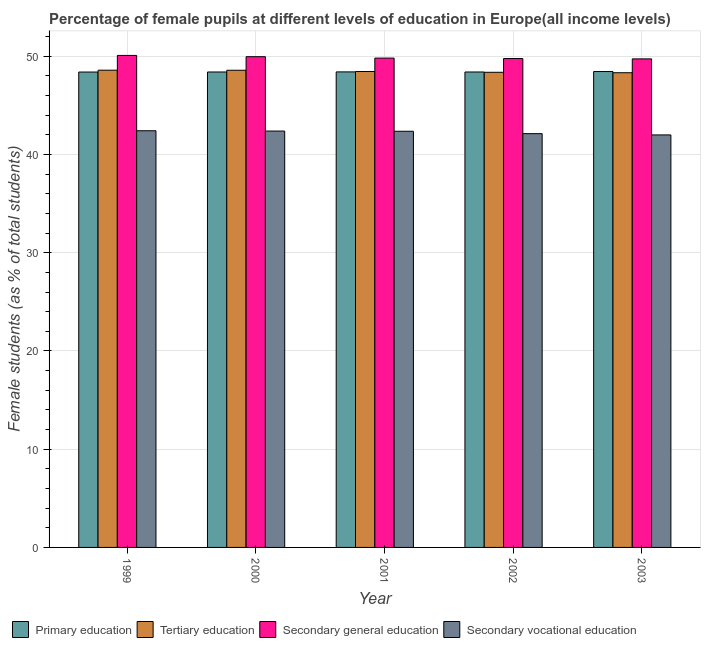How many different coloured bars are there?
Ensure brevity in your answer.  4. How many groups of bars are there?
Your answer should be very brief. 5. Are the number of bars per tick equal to the number of legend labels?
Provide a short and direct response. Yes. Are the number of bars on each tick of the X-axis equal?
Provide a short and direct response. Yes. How many bars are there on the 4th tick from the right?
Your answer should be very brief. 4. What is the label of the 2nd group of bars from the left?
Keep it short and to the point. 2000. In how many cases, is the number of bars for a given year not equal to the number of legend labels?
Make the answer very short. 0. What is the percentage of female students in secondary vocational education in 2000?
Offer a very short reply. 42.39. Across all years, what is the maximum percentage of female students in secondary education?
Your answer should be very brief. 50.09. Across all years, what is the minimum percentage of female students in primary education?
Your response must be concise. 48.4. In which year was the percentage of female students in secondary vocational education maximum?
Provide a short and direct response. 1999. In which year was the percentage of female students in tertiary education minimum?
Ensure brevity in your answer.  2003. What is the total percentage of female students in secondary vocational education in the graph?
Keep it short and to the point. 211.3. What is the difference between the percentage of female students in secondary vocational education in 2000 and that in 2001?
Make the answer very short. 0.02. What is the difference between the percentage of female students in secondary education in 2001 and the percentage of female students in tertiary education in 1999?
Your answer should be very brief. -0.27. What is the average percentage of female students in secondary vocational education per year?
Provide a short and direct response. 42.26. In the year 1999, what is the difference between the percentage of female students in tertiary education and percentage of female students in primary education?
Provide a short and direct response. 0. In how many years, is the percentage of female students in secondary education greater than 22 %?
Your answer should be compact. 5. What is the ratio of the percentage of female students in primary education in 1999 to that in 2002?
Your answer should be compact. 1. Is the difference between the percentage of female students in secondary education in 1999 and 2003 greater than the difference between the percentage of female students in secondary vocational education in 1999 and 2003?
Provide a short and direct response. No. What is the difference between the highest and the second highest percentage of female students in primary education?
Provide a succinct answer. 0.04. What is the difference between the highest and the lowest percentage of female students in tertiary education?
Give a very brief answer. 0.26. Is the sum of the percentage of female students in secondary vocational education in 1999 and 2001 greater than the maximum percentage of female students in primary education across all years?
Provide a succinct answer. Yes. Is it the case that in every year, the sum of the percentage of female students in tertiary education and percentage of female students in primary education is greater than the sum of percentage of female students in secondary education and percentage of female students in secondary vocational education?
Offer a very short reply. No. What does the 3rd bar from the left in 2001 represents?
Keep it short and to the point. Secondary general education. What does the 1st bar from the right in 2000 represents?
Offer a terse response. Secondary vocational education. Is it the case that in every year, the sum of the percentage of female students in primary education and percentage of female students in tertiary education is greater than the percentage of female students in secondary education?
Your response must be concise. Yes. How many bars are there?
Make the answer very short. 20. Are all the bars in the graph horizontal?
Offer a very short reply. No. Does the graph contain grids?
Make the answer very short. Yes. Where does the legend appear in the graph?
Provide a succinct answer. Bottom left. What is the title of the graph?
Offer a terse response. Percentage of female pupils at different levels of education in Europe(all income levels). What is the label or title of the X-axis?
Your response must be concise. Year. What is the label or title of the Y-axis?
Make the answer very short. Female students (as % of total students). What is the Female students (as % of total students) in Primary education in 1999?
Provide a short and direct response. 48.4. What is the Female students (as % of total students) of Tertiary education in 1999?
Provide a succinct answer. 48.59. What is the Female students (as % of total students) of Secondary general education in 1999?
Your answer should be very brief. 50.09. What is the Female students (as % of total students) in Secondary vocational education in 1999?
Give a very brief answer. 42.42. What is the Female students (as % of total students) of Primary education in 2000?
Your response must be concise. 48.4. What is the Female students (as % of total students) in Tertiary education in 2000?
Your answer should be very brief. 48.58. What is the Female students (as % of total students) of Secondary general education in 2000?
Provide a succinct answer. 49.96. What is the Female students (as % of total students) in Secondary vocational education in 2000?
Provide a succinct answer. 42.39. What is the Female students (as % of total students) in Primary education in 2001?
Make the answer very short. 48.41. What is the Female students (as % of total students) of Tertiary education in 2001?
Keep it short and to the point. 48.45. What is the Female students (as % of total students) of Secondary general education in 2001?
Offer a terse response. 49.82. What is the Female students (as % of total students) in Secondary vocational education in 2001?
Ensure brevity in your answer.  42.37. What is the Female students (as % of total students) of Primary education in 2002?
Keep it short and to the point. 48.4. What is the Female students (as % of total students) of Tertiary education in 2002?
Your answer should be very brief. 48.37. What is the Female students (as % of total students) of Secondary general education in 2002?
Your answer should be very brief. 49.77. What is the Female students (as % of total students) in Secondary vocational education in 2002?
Offer a terse response. 42.12. What is the Female students (as % of total students) in Primary education in 2003?
Offer a very short reply. 48.45. What is the Female students (as % of total students) in Tertiary education in 2003?
Make the answer very short. 48.33. What is the Female students (as % of total students) in Secondary general education in 2003?
Your answer should be very brief. 49.74. What is the Female students (as % of total students) of Secondary vocational education in 2003?
Your answer should be compact. 42. Across all years, what is the maximum Female students (as % of total students) in Primary education?
Make the answer very short. 48.45. Across all years, what is the maximum Female students (as % of total students) of Tertiary education?
Keep it short and to the point. 48.59. Across all years, what is the maximum Female students (as % of total students) in Secondary general education?
Ensure brevity in your answer.  50.09. Across all years, what is the maximum Female students (as % of total students) in Secondary vocational education?
Your response must be concise. 42.42. Across all years, what is the minimum Female students (as % of total students) in Primary education?
Keep it short and to the point. 48.4. Across all years, what is the minimum Female students (as % of total students) of Tertiary education?
Ensure brevity in your answer.  48.33. Across all years, what is the minimum Female students (as % of total students) in Secondary general education?
Ensure brevity in your answer.  49.74. Across all years, what is the minimum Female students (as % of total students) of Secondary vocational education?
Provide a succinct answer. 42. What is the total Female students (as % of total students) in Primary education in the graph?
Your answer should be very brief. 242.06. What is the total Female students (as % of total students) in Tertiary education in the graph?
Provide a succinct answer. 242.32. What is the total Female students (as % of total students) of Secondary general education in the graph?
Your response must be concise. 249.37. What is the total Female students (as % of total students) in Secondary vocational education in the graph?
Keep it short and to the point. 211.3. What is the difference between the Female students (as % of total students) in Primary education in 1999 and that in 2000?
Provide a short and direct response. -0.01. What is the difference between the Female students (as % of total students) of Tertiary education in 1999 and that in 2000?
Keep it short and to the point. 0.01. What is the difference between the Female students (as % of total students) of Secondary general education in 1999 and that in 2000?
Make the answer very short. 0.13. What is the difference between the Female students (as % of total students) in Secondary vocational education in 1999 and that in 2000?
Offer a terse response. 0.03. What is the difference between the Female students (as % of total students) of Primary education in 1999 and that in 2001?
Make the answer very short. -0.01. What is the difference between the Female students (as % of total students) in Tertiary education in 1999 and that in 2001?
Your answer should be compact. 0.13. What is the difference between the Female students (as % of total students) in Secondary general education in 1999 and that in 2001?
Offer a terse response. 0.27. What is the difference between the Female students (as % of total students) of Secondary vocational education in 1999 and that in 2001?
Make the answer very short. 0.05. What is the difference between the Female students (as % of total students) of Primary education in 1999 and that in 2002?
Make the answer very short. -0.01. What is the difference between the Female students (as % of total students) in Tertiary education in 1999 and that in 2002?
Provide a succinct answer. 0.21. What is the difference between the Female students (as % of total students) of Secondary general education in 1999 and that in 2002?
Give a very brief answer. 0.32. What is the difference between the Female students (as % of total students) in Secondary vocational education in 1999 and that in 2002?
Make the answer very short. 0.29. What is the difference between the Female students (as % of total students) of Primary education in 1999 and that in 2003?
Your response must be concise. -0.05. What is the difference between the Female students (as % of total students) of Tertiary education in 1999 and that in 2003?
Make the answer very short. 0.26. What is the difference between the Female students (as % of total students) in Secondary general education in 1999 and that in 2003?
Your response must be concise. 0.35. What is the difference between the Female students (as % of total students) in Secondary vocational education in 1999 and that in 2003?
Your response must be concise. 0.42. What is the difference between the Female students (as % of total students) of Primary education in 2000 and that in 2001?
Provide a short and direct response. -0.01. What is the difference between the Female students (as % of total students) in Tertiary education in 2000 and that in 2001?
Your response must be concise. 0.13. What is the difference between the Female students (as % of total students) of Secondary general education in 2000 and that in 2001?
Offer a very short reply. 0.14. What is the difference between the Female students (as % of total students) in Secondary vocational education in 2000 and that in 2001?
Provide a succinct answer. 0.02. What is the difference between the Female students (as % of total students) of Primary education in 2000 and that in 2002?
Keep it short and to the point. -0. What is the difference between the Female students (as % of total students) in Tertiary education in 2000 and that in 2002?
Make the answer very short. 0.21. What is the difference between the Female students (as % of total students) in Secondary general education in 2000 and that in 2002?
Keep it short and to the point. 0.19. What is the difference between the Female students (as % of total students) in Secondary vocational education in 2000 and that in 2002?
Keep it short and to the point. 0.26. What is the difference between the Female students (as % of total students) of Primary education in 2000 and that in 2003?
Your answer should be very brief. -0.05. What is the difference between the Female students (as % of total students) in Tertiary education in 2000 and that in 2003?
Your response must be concise. 0.25. What is the difference between the Female students (as % of total students) in Secondary general education in 2000 and that in 2003?
Provide a succinct answer. 0.22. What is the difference between the Female students (as % of total students) of Secondary vocational education in 2000 and that in 2003?
Offer a very short reply. 0.39. What is the difference between the Female students (as % of total students) of Primary education in 2001 and that in 2002?
Offer a terse response. 0.01. What is the difference between the Female students (as % of total students) of Tertiary education in 2001 and that in 2002?
Make the answer very short. 0.08. What is the difference between the Female students (as % of total students) in Secondary general education in 2001 and that in 2002?
Make the answer very short. 0.05. What is the difference between the Female students (as % of total students) in Secondary vocational education in 2001 and that in 2002?
Give a very brief answer. 0.24. What is the difference between the Female students (as % of total students) in Primary education in 2001 and that in 2003?
Keep it short and to the point. -0.04. What is the difference between the Female students (as % of total students) in Tertiary education in 2001 and that in 2003?
Offer a very short reply. 0.12. What is the difference between the Female students (as % of total students) in Secondary general education in 2001 and that in 2003?
Your answer should be compact. 0.08. What is the difference between the Female students (as % of total students) of Secondary vocational education in 2001 and that in 2003?
Make the answer very short. 0.37. What is the difference between the Female students (as % of total students) of Primary education in 2002 and that in 2003?
Your answer should be very brief. -0.05. What is the difference between the Female students (as % of total students) in Tertiary education in 2002 and that in 2003?
Ensure brevity in your answer.  0.05. What is the difference between the Female students (as % of total students) of Secondary general education in 2002 and that in 2003?
Ensure brevity in your answer.  0.03. What is the difference between the Female students (as % of total students) in Secondary vocational education in 2002 and that in 2003?
Provide a short and direct response. 0.13. What is the difference between the Female students (as % of total students) of Primary education in 1999 and the Female students (as % of total students) of Tertiary education in 2000?
Your response must be concise. -0.18. What is the difference between the Female students (as % of total students) in Primary education in 1999 and the Female students (as % of total students) in Secondary general education in 2000?
Give a very brief answer. -1.56. What is the difference between the Female students (as % of total students) in Primary education in 1999 and the Female students (as % of total students) in Secondary vocational education in 2000?
Offer a terse response. 6.01. What is the difference between the Female students (as % of total students) of Tertiary education in 1999 and the Female students (as % of total students) of Secondary general education in 2000?
Your response must be concise. -1.37. What is the difference between the Female students (as % of total students) of Tertiary education in 1999 and the Female students (as % of total students) of Secondary vocational education in 2000?
Provide a short and direct response. 6.2. What is the difference between the Female students (as % of total students) of Secondary general education in 1999 and the Female students (as % of total students) of Secondary vocational education in 2000?
Your response must be concise. 7.7. What is the difference between the Female students (as % of total students) of Primary education in 1999 and the Female students (as % of total students) of Tertiary education in 2001?
Keep it short and to the point. -0.06. What is the difference between the Female students (as % of total students) in Primary education in 1999 and the Female students (as % of total students) in Secondary general education in 2001?
Your answer should be very brief. -1.42. What is the difference between the Female students (as % of total students) in Primary education in 1999 and the Female students (as % of total students) in Secondary vocational education in 2001?
Make the answer very short. 6.03. What is the difference between the Female students (as % of total students) of Tertiary education in 1999 and the Female students (as % of total students) of Secondary general education in 2001?
Your answer should be compact. -1.23. What is the difference between the Female students (as % of total students) of Tertiary education in 1999 and the Female students (as % of total students) of Secondary vocational education in 2001?
Your answer should be compact. 6.22. What is the difference between the Female students (as % of total students) in Secondary general education in 1999 and the Female students (as % of total students) in Secondary vocational education in 2001?
Ensure brevity in your answer.  7.72. What is the difference between the Female students (as % of total students) in Primary education in 1999 and the Female students (as % of total students) in Tertiary education in 2002?
Provide a short and direct response. 0.02. What is the difference between the Female students (as % of total students) of Primary education in 1999 and the Female students (as % of total students) of Secondary general education in 2002?
Provide a short and direct response. -1.37. What is the difference between the Female students (as % of total students) in Primary education in 1999 and the Female students (as % of total students) in Secondary vocational education in 2002?
Keep it short and to the point. 6.27. What is the difference between the Female students (as % of total students) of Tertiary education in 1999 and the Female students (as % of total students) of Secondary general education in 2002?
Your answer should be very brief. -1.18. What is the difference between the Female students (as % of total students) in Tertiary education in 1999 and the Female students (as % of total students) in Secondary vocational education in 2002?
Offer a very short reply. 6.46. What is the difference between the Female students (as % of total students) in Secondary general education in 1999 and the Female students (as % of total students) in Secondary vocational education in 2002?
Offer a terse response. 7.96. What is the difference between the Female students (as % of total students) of Primary education in 1999 and the Female students (as % of total students) of Tertiary education in 2003?
Offer a terse response. 0.07. What is the difference between the Female students (as % of total students) in Primary education in 1999 and the Female students (as % of total students) in Secondary general education in 2003?
Your answer should be compact. -1.34. What is the difference between the Female students (as % of total students) in Primary education in 1999 and the Female students (as % of total students) in Secondary vocational education in 2003?
Offer a terse response. 6.4. What is the difference between the Female students (as % of total students) of Tertiary education in 1999 and the Female students (as % of total students) of Secondary general education in 2003?
Offer a terse response. -1.15. What is the difference between the Female students (as % of total students) in Tertiary education in 1999 and the Female students (as % of total students) in Secondary vocational education in 2003?
Provide a short and direct response. 6.59. What is the difference between the Female students (as % of total students) of Secondary general education in 1999 and the Female students (as % of total students) of Secondary vocational education in 2003?
Give a very brief answer. 8.09. What is the difference between the Female students (as % of total students) in Primary education in 2000 and the Female students (as % of total students) in Tertiary education in 2001?
Provide a short and direct response. -0.05. What is the difference between the Female students (as % of total students) of Primary education in 2000 and the Female students (as % of total students) of Secondary general education in 2001?
Keep it short and to the point. -1.41. What is the difference between the Female students (as % of total students) in Primary education in 2000 and the Female students (as % of total students) in Secondary vocational education in 2001?
Provide a short and direct response. 6.03. What is the difference between the Female students (as % of total students) of Tertiary education in 2000 and the Female students (as % of total students) of Secondary general education in 2001?
Give a very brief answer. -1.24. What is the difference between the Female students (as % of total students) of Tertiary education in 2000 and the Female students (as % of total students) of Secondary vocational education in 2001?
Your answer should be compact. 6.21. What is the difference between the Female students (as % of total students) in Secondary general education in 2000 and the Female students (as % of total students) in Secondary vocational education in 2001?
Offer a very short reply. 7.59. What is the difference between the Female students (as % of total students) of Primary education in 2000 and the Female students (as % of total students) of Tertiary education in 2002?
Offer a very short reply. 0.03. What is the difference between the Female students (as % of total students) of Primary education in 2000 and the Female students (as % of total students) of Secondary general education in 2002?
Your answer should be compact. -1.37. What is the difference between the Female students (as % of total students) of Primary education in 2000 and the Female students (as % of total students) of Secondary vocational education in 2002?
Make the answer very short. 6.28. What is the difference between the Female students (as % of total students) in Tertiary education in 2000 and the Female students (as % of total students) in Secondary general education in 2002?
Your answer should be very brief. -1.19. What is the difference between the Female students (as % of total students) in Tertiary education in 2000 and the Female students (as % of total students) in Secondary vocational education in 2002?
Keep it short and to the point. 6.45. What is the difference between the Female students (as % of total students) of Secondary general education in 2000 and the Female students (as % of total students) of Secondary vocational education in 2002?
Offer a terse response. 7.83. What is the difference between the Female students (as % of total students) in Primary education in 2000 and the Female students (as % of total students) in Tertiary education in 2003?
Make the answer very short. 0.07. What is the difference between the Female students (as % of total students) of Primary education in 2000 and the Female students (as % of total students) of Secondary general education in 2003?
Make the answer very short. -1.33. What is the difference between the Female students (as % of total students) in Primary education in 2000 and the Female students (as % of total students) in Secondary vocational education in 2003?
Offer a terse response. 6.41. What is the difference between the Female students (as % of total students) in Tertiary education in 2000 and the Female students (as % of total students) in Secondary general education in 2003?
Your response must be concise. -1.16. What is the difference between the Female students (as % of total students) in Tertiary education in 2000 and the Female students (as % of total students) in Secondary vocational education in 2003?
Give a very brief answer. 6.58. What is the difference between the Female students (as % of total students) of Secondary general education in 2000 and the Female students (as % of total students) of Secondary vocational education in 2003?
Make the answer very short. 7.96. What is the difference between the Female students (as % of total students) of Primary education in 2001 and the Female students (as % of total students) of Tertiary education in 2002?
Provide a short and direct response. 0.04. What is the difference between the Female students (as % of total students) of Primary education in 2001 and the Female students (as % of total students) of Secondary general education in 2002?
Give a very brief answer. -1.36. What is the difference between the Female students (as % of total students) in Primary education in 2001 and the Female students (as % of total students) in Secondary vocational education in 2002?
Your answer should be very brief. 6.29. What is the difference between the Female students (as % of total students) in Tertiary education in 2001 and the Female students (as % of total students) in Secondary general education in 2002?
Your response must be concise. -1.32. What is the difference between the Female students (as % of total students) of Tertiary education in 2001 and the Female students (as % of total students) of Secondary vocational education in 2002?
Keep it short and to the point. 6.33. What is the difference between the Female students (as % of total students) in Secondary general education in 2001 and the Female students (as % of total students) in Secondary vocational education in 2002?
Your response must be concise. 7.69. What is the difference between the Female students (as % of total students) of Primary education in 2001 and the Female students (as % of total students) of Tertiary education in 2003?
Offer a terse response. 0.08. What is the difference between the Female students (as % of total students) in Primary education in 2001 and the Female students (as % of total students) in Secondary general education in 2003?
Give a very brief answer. -1.32. What is the difference between the Female students (as % of total students) in Primary education in 2001 and the Female students (as % of total students) in Secondary vocational education in 2003?
Provide a succinct answer. 6.42. What is the difference between the Female students (as % of total students) in Tertiary education in 2001 and the Female students (as % of total students) in Secondary general education in 2003?
Provide a short and direct response. -1.28. What is the difference between the Female students (as % of total students) in Tertiary education in 2001 and the Female students (as % of total students) in Secondary vocational education in 2003?
Provide a short and direct response. 6.46. What is the difference between the Female students (as % of total students) in Secondary general education in 2001 and the Female students (as % of total students) in Secondary vocational education in 2003?
Keep it short and to the point. 7.82. What is the difference between the Female students (as % of total students) of Primary education in 2002 and the Female students (as % of total students) of Tertiary education in 2003?
Provide a succinct answer. 0.08. What is the difference between the Female students (as % of total students) in Primary education in 2002 and the Female students (as % of total students) in Secondary general education in 2003?
Your response must be concise. -1.33. What is the difference between the Female students (as % of total students) in Primary education in 2002 and the Female students (as % of total students) in Secondary vocational education in 2003?
Provide a succinct answer. 6.41. What is the difference between the Female students (as % of total students) in Tertiary education in 2002 and the Female students (as % of total students) in Secondary general education in 2003?
Provide a short and direct response. -1.36. What is the difference between the Female students (as % of total students) in Tertiary education in 2002 and the Female students (as % of total students) in Secondary vocational education in 2003?
Ensure brevity in your answer.  6.38. What is the difference between the Female students (as % of total students) of Secondary general education in 2002 and the Female students (as % of total students) of Secondary vocational education in 2003?
Keep it short and to the point. 7.77. What is the average Female students (as % of total students) in Primary education per year?
Your response must be concise. 48.41. What is the average Female students (as % of total students) of Tertiary education per year?
Give a very brief answer. 48.46. What is the average Female students (as % of total students) of Secondary general education per year?
Keep it short and to the point. 49.87. What is the average Female students (as % of total students) in Secondary vocational education per year?
Ensure brevity in your answer.  42.26. In the year 1999, what is the difference between the Female students (as % of total students) in Primary education and Female students (as % of total students) in Tertiary education?
Offer a terse response. -0.19. In the year 1999, what is the difference between the Female students (as % of total students) in Primary education and Female students (as % of total students) in Secondary general education?
Offer a very short reply. -1.69. In the year 1999, what is the difference between the Female students (as % of total students) in Primary education and Female students (as % of total students) in Secondary vocational education?
Make the answer very short. 5.98. In the year 1999, what is the difference between the Female students (as % of total students) of Tertiary education and Female students (as % of total students) of Secondary general education?
Offer a very short reply. -1.5. In the year 1999, what is the difference between the Female students (as % of total students) in Tertiary education and Female students (as % of total students) in Secondary vocational education?
Make the answer very short. 6.17. In the year 1999, what is the difference between the Female students (as % of total students) of Secondary general education and Female students (as % of total students) of Secondary vocational education?
Keep it short and to the point. 7.67. In the year 2000, what is the difference between the Female students (as % of total students) of Primary education and Female students (as % of total students) of Tertiary education?
Ensure brevity in your answer.  -0.18. In the year 2000, what is the difference between the Female students (as % of total students) of Primary education and Female students (as % of total students) of Secondary general education?
Keep it short and to the point. -1.56. In the year 2000, what is the difference between the Female students (as % of total students) of Primary education and Female students (as % of total students) of Secondary vocational education?
Give a very brief answer. 6.01. In the year 2000, what is the difference between the Female students (as % of total students) in Tertiary education and Female students (as % of total students) in Secondary general education?
Keep it short and to the point. -1.38. In the year 2000, what is the difference between the Female students (as % of total students) of Tertiary education and Female students (as % of total students) of Secondary vocational education?
Give a very brief answer. 6.19. In the year 2000, what is the difference between the Female students (as % of total students) in Secondary general education and Female students (as % of total students) in Secondary vocational education?
Provide a short and direct response. 7.57. In the year 2001, what is the difference between the Female students (as % of total students) in Primary education and Female students (as % of total students) in Tertiary education?
Give a very brief answer. -0.04. In the year 2001, what is the difference between the Female students (as % of total students) of Primary education and Female students (as % of total students) of Secondary general education?
Provide a short and direct response. -1.41. In the year 2001, what is the difference between the Female students (as % of total students) of Primary education and Female students (as % of total students) of Secondary vocational education?
Provide a short and direct response. 6.04. In the year 2001, what is the difference between the Female students (as % of total students) of Tertiary education and Female students (as % of total students) of Secondary general education?
Your response must be concise. -1.36. In the year 2001, what is the difference between the Female students (as % of total students) in Tertiary education and Female students (as % of total students) in Secondary vocational education?
Make the answer very short. 6.08. In the year 2001, what is the difference between the Female students (as % of total students) in Secondary general education and Female students (as % of total students) in Secondary vocational education?
Keep it short and to the point. 7.45. In the year 2002, what is the difference between the Female students (as % of total students) in Primary education and Female students (as % of total students) in Tertiary education?
Keep it short and to the point. 0.03. In the year 2002, what is the difference between the Female students (as % of total students) in Primary education and Female students (as % of total students) in Secondary general education?
Provide a succinct answer. -1.37. In the year 2002, what is the difference between the Female students (as % of total students) in Primary education and Female students (as % of total students) in Secondary vocational education?
Provide a succinct answer. 6.28. In the year 2002, what is the difference between the Female students (as % of total students) in Tertiary education and Female students (as % of total students) in Secondary general education?
Keep it short and to the point. -1.4. In the year 2002, what is the difference between the Female students (as % of total students) in Tertiary education and Female students (as % of total students) in Secondary vocational education?
Your answer should be compact. 6.25. In the year 2002, what is the difference between the Female students (as % of total students) of Secondary general education and Female students (as % of total students) of Secondary vocational education?
Your answer should be compact. 7.64. In the year 2003, what is the difference between the Female students (as % of total students) of Primary education and Female students (as % of total students) of Tertiary education?
Offer a very short reply. 0.12. In the year 2003, what is the difference between the Female students (as % of total students) of Primary education and Female students (as % of total students) of Secondary general education?
Provide a short and direct response. -1.29. In the year 2003, what is the difference between the Female students (as % of total students) in Primary education and Female students (as % of total students) in Secondary vocational education?
Provide a succinct answer. 6.45. In the year 2003, what is the difference between the Female students (as % of total students) of Tertiary education and Female students (as % of total students) of Secondary general education?
Offer a terse response. -1.41. In the year 2003, what is the difference between the Female students (as % of total students) in Tertiary education and Female students (as % of total students) in Secondary vocational education?
Give a very brief answer. 6.33. In the year 2003, what is the difference between the Female students (as % of total students) of Secondary general education and Female students (as % of total students) of Secondary vocational education?
Keep it short and to the point. 7.74. What is the ratio of the Female students (as % of total students) of Primary education in 1999 to that in 2001?
Provide a short and direct response. 1. What is the ratio of the Female students (as % of total students) of Tertiary education in 1999 to that in 2001?
Give a very brief answer. 1. What is the ratio of the Female students (as % of total students) of Secondary vocational education in 1999 to that in 2001?
Make the answer very short. 1. What is the ratio of the Female students (as % of total students) in Tertiary education in 1999 to that in 2002?
Offer a terse response. 1. What is the ratio of the Female students (as % of total students) in Secondary general education in 1999 to that in 2002?
Provide a succinct answer. 1.01. What is the ratio of the Female students (as % of total students) of Secondary vocational education in 1999 to that in 2002?
Make the answer very short. 1.01. What is the ratio of the Female students (as % of total students) of Primary education in 1999 to that in 2003?
Keep it short and to the point. 1. What is the ratio of the Female students (as % of total students) in Tertiary education in 1999 to that in 2003?
Keep it short and to the point. 1.01. What is the ratio of the Female students (as % of total students) in Secondary general education in 1999 to that in 2003?
Provide a short and direct response. 1.01. What is the ratio of the Female students (as % of total students) in Primary education in 2000 to that in 2001?
Keep it short and to the point. 1. What is the ratio of the Female students (as % of total students) in Tertiary education in 2000 to that in 2001?
Provide a succinct answer. 1. What is the ratio of the Female students (as % of total students) in Secondary general education in 2000 to that in 2001?
Make the answer very short. 1. What is the ratio of the Female students (as % of total students) in Secondary vocational education in 2000 to that in 2001?
Your response must be concise. 1. What is the ratio of the Female students (as % of total students) of Tertiary education in 2000 to that in 2002?
Keep it short and to the point. 1. What is the ratio of the Female students (as % of total students) in Secondary general education in 2000 to that in 2002?
Your answer should be very brief. 1. What is the ratio of the Female students (as % of total students) in Primary education in 2000 to that in 2003?
Provide a short and direct response. 1. What is the ratio of the Female students (as % of total students) in Tertiary education in 2000 to that in 2003?
Give a very brief answer. 1.01. What is the ratio of the Female students (as % of total students) in Secondary vocational education in 2000 to that in 2003?
Provide a succinct answer. 1.01. What is the ratio of the Female students (as % of total students) of Tertiary education in 2001 to that in 2002?
Offer a terse response. 1. What is the ratio of the Female students (as % of total students) of Secondary general education in 2001 to that in 2002?
Provide a succinct answer. 1. What is the ratio of the Female students (as % of total students) in Secondary vocational education in 2001 to that in 2002?
Offer a very short reply. 1.01. What is the ratio of the Female students (as % of total students) of Primary education in 2001 to that in 2003?
Give a very brief answer. 1. What is the ratio of the Female students (as % of total students) in Tertiary education in 2001 to that in 2003?
Your response must be concise. 1. What is the ratio of the Female students (as % of total students) in Secondary vocational education in 2001 to that in 2003?
Provide a succinct answer. 1.01. What is the ratio of the Female students (as % of total students) in Secondary general education in 2002 to that in 2003?
Provide a short and direct response. 1. What is the difference between the highest and the second highest Female students (as % of total students) in Primary education?
Provide a short and direct response. 0.04. What is the difference between the highest and the second highest Female students (as % of total students) in Tertiary education?
Your answer should be compact. 0.01. What is the difference between the highest and the second highest Female students (as % of total students) of Secondary general education?
Offer a very short reply. 0.13. What is the difference between the highest and the second highest Female students (as % of total students) in Secondary vocational education?
Offer a very short reply. 0.03. What is the difference between the highest and the lowest Female students (as % of total students) of Primary education?
Keep it short and to the point. 0.05. What is the difference between the highest and the lowest Female students (as % of total students) of Tertiary education?
Give a very brief answer. 0.26. What is the difference between the highest and the lowest Female students (as % of total students) of Secondary general education?
Make the answer very short. 0.35. What is the difference between the highest and the lowest Female students (as % of total students) in Secondary vocational education?
Give a very brief answer. 0.42. 